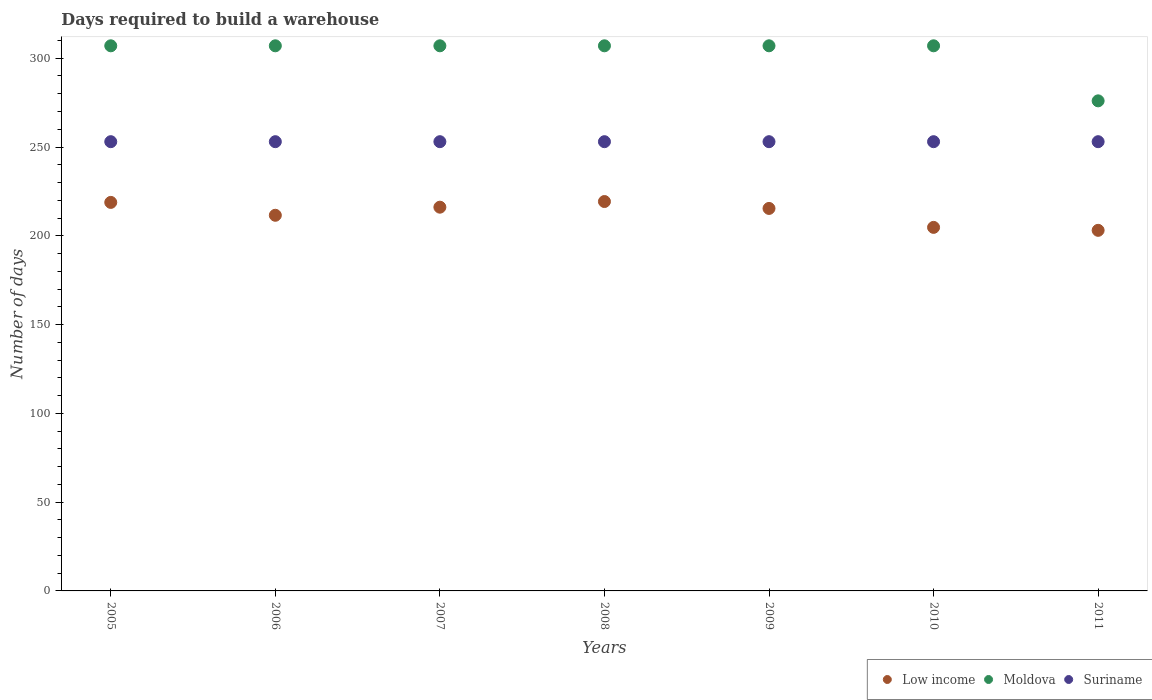Is the number of dotlines equal to the number of legend labels?
Provide a succinct answer. Yes. What is the days required to build a warehouse in in Low income in 2008?
Keep it short and to the point. 219.3. Across all years, what is the maximum days required to build a warehouse in in Moldova?
Your answer should be compact. 307. Across all years, what is the minimum days required to build a warehouse in in Suriname?
Keep it short and to the point. 253. What is the total days required to build a warehouse in in Suriname in the graph?
Make the answer very short. 1771. What is the difference between the days required to build a warehouse in in Moldova in 2006 and that in 2009?
Keep it short and to the point. 0. What is the difference between the days required to build a warehouse in in Moldova in 2009 and the days required to build a warehouse in in Low income in 2007?
Give a very brief answer. 90.89. What is the average days required to build a warehouse in in Low income per year?
Give a very brief answer. 212.71. In the year 2007, what is the difference between the days required to build a warehouse in in Low income and days required to build a warehouse in in Suriname?
Keep it short and to the point. -36.89. In how many years, is the days required to build a warehouse in in Moldova greater than 130 days?
Offer a very short reply. 7. What is the ratio of the days required to build a warehouse in in Suriname in 2006 to that in 2008?
Ensure brevity in your answer.  1. Is the difference between the days required to build a warehouse in in Low income in 2005 and 2011 greater than the difference between the days required to build a warehouse in in Suriname in 2005 and 2011?
Keep it short and to the point. Yes. What is the difference between the highest and the second highest days required to build a warehouse in in Suriname?
Your response must be concise. 0. What is the difference between the highest and the lowest days required to build a warehouse in in Suriname?
Provide a short and direct response. 0. In how many years, is the days required to build a warehouse in in Moldova greater than the average days required to build a warehouse in in Moldova taken over all years?
Offer a very short reply. 6. Is the sum of the days required to build a warehouse in in Moldova in 2005 and 2008 greater than the maximum days required to build a warehouse in in Low income across all years?
Give a very brief answer. Yes. Does the days required to build a warehouse in in Moldova monotonically increase over the years?
Ensure brevity in your answer.  No. Is the days required to build a warehouse in in Moldova strictly greater than the days required to build a warehouse in in Suriname over the years?
Ensure brevity in your answer.  Yes. Is the days required to build a warehouse in in Moldova strictly less than the days required to build a warehouse in in Low income over the years?
Your response must be concise. No. How many dotlines are there?
Give a very brief answer. 3. What is the difference between two consecutive major ticks on the Y-axis?
Give a very brief answer. 50. Are the values on the major ticks of Y-axis written in scientific E-notation?
Your response must be concise. No. Does the graph contain grids?
Ensure brevity in your answer.  No. Where does the legend appear in the graph?
Make the answer very short. Bottom right. How many legend labels are there?
Your response must be concise. 3. How are the legend labels stacked?
Give a very brief answer. Horizontal. What is the title of the graph?
Your response must be concise. Days required to build a warehouse. What is the label or title of the X-axis?
Provide a short and direct response. Years. What is the label or title of the Y-axis?
Your answer should be very brief. Number of days. What is the Number of days of Low income in 2005?
Your answer should be very brief. 218.81. What is the Number of days of Moldova in 2005?
Your response must be concise. 307. What is the Number of days of Suriname in 2005?
Offer a terse response. 253. What is the Number of days in Low income in 2006?
Ensure brevity in your answer.  211.56. What is the Number of days of Moldova in 2006?
Provide a short and direct response. 307. What is the Number of days in Suriname in 2006?
Offer a terse response. 253. What is the Number of days in Low income in 2007?
Make the answer very short. 216.11. What is the Number of days in Moldova in 2007?
Your response must be concise. 307. What is the Number of days of Suriname in 2007?
Give a very brief answer. 253. What is the Number of days in Low income in 2008?
Offer a very short reply. 219.3. What is the Number of days in Moldova in 2008?
Give a very brief answer. 307. What is the Number of days in Suriname in 2008?
Make the answer very short. 253. What is the Number of days of Low income in 2009?
Give a very brief answer. 215.41. What is the Number of days in Moldova in 2009?
Offer a terse response. 307. What is the Number of days in Suriname in 2009?
Provide a succinct answer. 253. What is the Number of days in Low income in 2010?
Ensure brevity in your answer.  204.74. What is the Number of days in Moldova in 2010?
Provide a succinct answer. 307. What is the Number of days of Suriname in 2010?
Offer a very short reply. 253. What is the Number of days of Low income in 2011?
Make the answer very short. 203.07. What is the Number of days of Moldova in 2011?
Offer a terse response. 276. What is the Number of days of Suriname in 2011?
Your answer should be compact. 253. Across all years, what is the maximum Number of days of Low income?
Keep it short and to the point. 219.3. Across all years, what is the maximum Number of days of Moldova?
Make the answer very short. 307. Across all years, what is the maximum Number of days in Suriname?
Offer a very short reply. 253. Across all years, what is the minimum Number of days of Low income?
Ensure brevity in your answer.  203.07. Across all years, what is the minimum Number of days of Moldova?
Provide a short and direct response. 276. Across all years, what is the minimum Number of days of Suriname?
Make the answer very short. 253. What is the total Number of days in Low income in the graph?
Make the answer very short. 1488.99. What is the total Number of days in Moldova in the graph?
Your answer should be compact. 2118. What is the total Number of days in Suriname in the graph?
Make the answer very short. 1771. What is the difference between the Number of days in Low income in 2005 and that in 2006?
Ensure brevity in your answer.  7.25. What is the difference between the Number of days of Low income in 2005 and that in 2007?
Offer a terse response. 2.7. What is the difference between the Number of days of Moldova in 2005 and that in 2007?
Your answer should be compact. 0. What is the difference between the Number of days of Suriname in 2005 and that in 2007?
Offer a terse response. 0. What is the difference between the Number of days in Low income in 2005 and that in 2008?
Provide a succinct answer. -0.49. What is the difference between the Number of days in Suriname in 2005 and that in 2008?
Ensure brevity in your answer.  0. What is the difference between the Number of days of Low income in 2005 and that in 2009?
Provide a succinct answer. 3.4. What is the difference between the Number of days of Low income in 2005 and that in 2010?
Ensure brevity in your answer.  14.07. What is the difference between the Number of days of Moldova in 2005 and that in 2010?
Provide a succinct answer. 0. What is the difference between the Number of days in Low income in 2005 and that in 2011?
Your response must be concise. 15.73. What is the difference between the Number of days of Suriname in 2005 and that in 2011?
Offer a very short reply. 0. What is the difference between the Number of days of Low income in 2006 and that in 2007?
Make the answer very short. -4.56. What is the difference between the Number of days in Low income in 2006 and that in 2008?
Offer a very short reply. -7.74. What is the difference between the Number of days in Moldova in 2006 and that in 2008?
Make the answer very short. 0. What is the difference between the Number of days of Suriname in 2006 and that in 2008?
Give a very brief answer. 0. What is the difference between the Number of days in Low income in 2006 and that in 2009?
Give a very brief answer. -3.85. What is the difference between the Number of days in Suriname in 2006 and that in 2009?
Provide a short and direct response. 0. What is the difference between the Number of days of Low income in 2006 and that in 2010?
Your answer should be very brief. 6.81. What is the difference between the Number of days of Low income in 2006 and that in 2011?
Keep it short and to the point. 8.48. What is the difference between the Number of days in Suriname in 2006 and that in 2011?
Provide a short and direct response. 0. What is the difference between the Number of days in Low income in 2007 and that in 2008?
Provide a succinct answer. -3.19. What is the difference between the Number of days of Suriname in 2007 and that in 2008?
Offer a terse response. 0. What is the difference between the Number of days in Low income in 2007 and that in 2009?
Your response must be concise. 0.7. What is the difference between the Number of days in Moldova in 2007 and that in 2009?
Ensure brevity in your answer.  0. What is the difference between the Number of days in Low income in 2007 and that in 2010?
Provide a short and direct response. 11.37. What is the difference between the Number of days in Moldova in 2007 and that in 2010?
Your answer should be very brief. 0. What is the difference between the Number of days of Suriname in 2007 and that in 2010?
Your response must be concise. 0. What is the difference between the Number of days of Low income in 2007 and that in 2011?
Give a very brief answer. 13.04. What is the difference between the Number of days of Moldova in 2007 and that in 2011?
Give a very brief answer. 31. What is the difference between the Number of days of Suriname in 2007 and that in 2011?
Offer a very short reply. 0. What is the difference between the Number of days of Low income in 2008 and that in 2009?
Ensure brevity in your answer.  3.89. What is the difference between the Number of days in Moldova in 2008 and that in 2009?
Provide a succinct answer. 0. What is the difference between the Number of days of Suriname in 2008 and that in 2009?
Your answer should be very brief. 0. What is the difference between the Number of days of Low income in 2008 and that in 2010?
Ensure brevity in your answer.  14.56. What is the difference between the Number of days of Moldova in 2008 and that in 2010?
Provide a succinct answer. 0. What is the difference between the Number of days in Low income in 2008 and that in 2011?
Provide a short and direct response. 16.22. What is the difference between the Number of days of Suriname in 2008 and that in 2011?
Your response must be concise. 0. What is the difference between the Number of days in Low income in 2009 and that in 2010?
Your response must be concise. 10.67. What is the difference between the Number of days of Moldova in 2009 and that in 2010?
Offer a terse response. 0. What is the difference between the Number of days of Suriname in 2009 and that in 2010?
Offer a very short reply. 0. What is the difference between the Number of days in Low income in 2009 and that in 2011?
Provide a short and direct response. 12.33. What is the difference between the Number of days in Suriname in 2010 and that in 2011?
Make the answer very short. 0. What is the difference between the Number of days in Low income in 2005 and the Number of days in Moldova in 2006?
Your response must be concise. -88.19. What is the difference between the Number of days of Low income in 2005 and the Number of days of Suriname in 2006?
Provide a succinct answer. -34.19. What is the difference between the Number of days of Low income in 2005 and the Number of days of Moldova in 2007?
Provide a short and direct response. -88.19. What is the difference between the Number of days of Low income in 2005 and the Number of days of Suriname in 2007?
Provide a succinct answer. -34.19. What is the difference between the Number of days in Moldova in 2005 and the Number of days in Suriname in 2007?
Your response must be concise. 54. What is the difference between the Number of days of Low income in 2005 and the Number of days of Moldova in 2008?
Your answer should be very brief. -88.19. What is the difference between the Number of days in Low income in 2005 and the Number of days in Suriname in 2008?
Your answer should be very brief. -34.19. What is the difference between the Number of days of Moldova in 2005 and the Number of days of Suriname in 2008?
Ensure brevity in your answer.  54. What is the difference between the Number of days of Low income in 2005 and the Number of days of Moldova in 2009?
Provide a succinct answer. -88.19. What is the difference between the Number of days of Low income in 2005 and the Number of days of Suriname in 2009?
Your answer should be compact. -34.19. What is the difference between the Number of days of Low income in 2005 and the Number of days of Moldova in 2010?
Make the answer very short. -88.19. What is the difference between the Number of days of Low income in 2005 and the Number of days of Suriname in 2010?
Give a very brief answer. -34.19. What is the difference between the Number of days in Low income in 2005 and the Number of days in Moldova in 2011?
Make the answer very short. -57.19. What is the difference between the Number of days in Low income in 2005 and the Number of days in Suriname in 2011?
Keep it short and to the point. -34.19. What is the difference between the Number of days in Low income in 2006 and the Number of days in Moldova in 2007?
Your answer should be compact. -95.44. What is the difference between the Number of days of Low income in 2006 and the Number of days of Suriname in 2007?
Ensure brevity in your answer.  -41.44. What is the difference between the Number of days of Moldova in 2006 and the Number of days of Suriname in 2007?
Give a very brief answer. 54. What is the difference between the Number of days in Low income in 2006 and the Number of days in Moldova in 2008?
Keep it short and to the point. -95.44. What is the difference between the Number of days in Low income in 2006 and the Number of days in Suriname in 2008?
Your answer should be compact. -41.44. What is the difference between the Number of days in Low income in 2006 and the Number of days in Moldova in 2009?
Your answer should be compact. -95.44. What is the difference between the Number of days in Low income in 2006 and the Number of days in Suriname in 2009?
Provide a succinct answer. -41.44. What is the difference between the Number of days in Low income in 2006 and the Number of days in Moldova in 2010?
Provide a short and direct response. -95.44. What is the difference between the Number of days in Low income in 2006 and the Number of days in Suriname in 2010?
Offer a terse response. -41.44. What is the difference between the Number of days of Moldova in 2006 and the Number of days of Suriname in 2010?
Keep it short and to the point. 54. What is the difference between the Number of days in Low income in 2006 and the Number of days in Moldova in 2011?
Give a very brief answer. -64.44. What is the difference between the Number of days in Low income in 2006 and the Number of days in Suriname in 2011?
Make the answer very short. -41.44. What is the difference between the Number of days in Moldova in 2006 and the Number of days in Suriname in 2011?
Provide a short and direct response. 54. What is the difference between the Number of days of Low income in 2007 and the Number of days of Moldova in 2008?
Ensure brevity in your answer.  -90.89. What is the difference between the Number of days of Low income in 2007 and the Number of days of Suriname in 2008?
Your answer should be very brief. -36.89. What is the difference between the Number of days of Moldova in 2007 and the Number of days of Suriname in 2008?
Offer a very short reply. 54. What is the difference between the Number of days of Low income in 2007 and the Number of days of Moldova in 2009?
Your answer should be compact. -90.89. What is the difference between the Number of days in Low income in 2007 and the Number of days in Suriname in 2009?
Offer a terse response. -36.89. What is the difference between the Number of days in Low income in 2007 and the Number of days in Moldova in 2010?
Ensure brevity in your answer.  -90.89. What is the difference between the Number of days of Low income in 2007 and the Number of days of Suriname in 2010?
Provide a succinct answer. -36.89. What is the difference between the Number of days of Moldova in 2007 and the Number of days of Suriname in 2010?
Provide a short and direct response. 54. What is the difference between the Number of days of Low income in 2007 and the Number of days of Moldova in 2011?
Your answer should be compact. -59.89. What is the difference between the Number of days in Low income in 2007 and the Number of days in Suriname in 2011?
Keep it short and to the point. -36.89. What is the difference between the Number of days of Moldova in 2007 and the Number of days of Suriname in 2011?
Make the answer very short. 54. What is the difference between the Number of days in Low income in 2008 and the Number of days in Moldova in 2009?
Provide a short and direct response. -87.7. What is the difference between the Number of days of Low income in 2008 and the Number of days of Suriname in 2009?
Provide a short and direct response. -33.7. What is the difference between the Number of days of Low income in 2008 and the Number of days of Moldova in 2010?
Offer a very short reply. -87.7. What is the difference between the Number of days in Low income in 2008 and the Number of days in Suriname in 2010?
Offer a very short reply. -33.7. What is the difference between the Number of days of Moldova in 2008 and the Number of days of Suriname in 2010?
Your response must be concise. 54. What is the difference between the Number of days of Low income in 2008 and the Number of days of Moldova in 2011?
Make the answer very short. -56.7. What is the difference between the Number of days in Low income in 2008 and the Number of days in Suriname in 2011?
Offer a very short reply. -33.7. What is the difference between the Number of days of Low income in 2009 and the Number of days of Moldova in 2010?
Keep it short and to the point. -91.59. What is the difference between the Number of days in Low income in 2009 and the Number of days in Suriname in 2010?
Keep it short and to the point. -37.59. What is the difference between the Number of days of Low income in 2009 and the Number of days of Moldova in 2011?
Provide a short and direct response. -60.59. What is the difference between the Number of days of Low income in 2009 and the Number of days of Suriname in 2011?
Give a very brief answer. -37.59. What is the difference between the Number of days in Low income in 2010 and the Number of days in Moldova in 2011?
Ensure brevity in your answer.  -71.26. What is the difference between the Number of days of Low income in 2010 and the Number of days of Suriname in 2011?
Keep it short and to the point. -48.26. What is the average Number of days in Low income per year?
Your answer should be very brief. 212.71. What is the average Number of days in Moldova per year?
Offer a very short reply. 302.57. What is the average Number of days in Suriname per year?
Your answer should be compact. 253. In the year 2005, what is the difference between the Number of days of Low income and Number of days of Moldova?
Provide a succinct answer. -88.19. In the year 2005, what is the difference between the Number of days in Low income and Number of days in Suriname?
Your answer should be very brief. -34.19. In the year 2005, what is the difference between the Number of days in Moldova and Number of days in Suriname?
Make the answer very short. 54. In the year 2006, what is the difference between the Number of days of Low income and Number of days of Moldova?
Make the answer very short. -95.44. In the year 2006, what is the difference between the Number of days of Low income and Number of days of Suriname?
Ensure brevity in your answer.  -41.44. In the year 2006, what is the difference between the Number of days in Moldova and Number of days in Suriname?
Keep it short and to the point. 54. In the year 2007, what is the difference between the Number of days of Low income and Number of days of Moldova?
Offer a terse response. -90.89. In the year 2007, what is the difference between the Number of days in Low income and Number of days in Suriname?
Offer a very short reply. -36.89. In the year 2008, what is the difference between the Number of days in Low income and Number of days in Moldova?
Offer a terse response. -87.7. In the year 2008, what is the difference between the Number of days of Low income and Number of days of Suriname?
Your answer should be very brief. -33.7. In the year 2009, what is the difference between the Number of days of Low income and Number of days of Moldova?
Your response must be concise. -91.59. In the year 2009, what is the difference between the Number of days in Low income and Number of days in Suriname?
Provide a succinct answer. -37.59. In the year 2009, what is the difference between the Number of days in Moldova and Number of days in Suriname?
Offer a very short reply. 54. In the year 2010, what is the difference between the Number of days of Low income and Number of days of Moldova?
Offer a terse response. -102.26. In the year 2010, what is the difference between the Number of days of Low income and Number of days of Suriname?
Ensure brevity in your answer.  -48.26. In the year 2011, what is the difference between the Number of days of Low income and Number of days of Moldova?
Provide a short and direct response. -72.93. In the year 2011, what is the difference between the Number of days in Low income and Number of days in Suriname?
Your response must be concise. -49.93. In the year 2011, what is the difference between the Number of days of Moldova and Number of days of Suriname?
Your answer should be very brief. 23. What is the ratio of the Number of days in Low income in 2005 to that in 2006?
Offer a terse response. 1.03. What is the ratio of the Number of days in Suriname in 2005 to that in 2006?
Ensure brevity in your answer.  1. What is the ratio of the Number of days in Low income in 2005 to that in 2007?
Your response must be concise. 1.01. What is the ratio of the Number of days of Moldova in 2005 to that in 2007?
Your answer should be very brief. 1. What is the ratio of the Number of days in Low income in 2005 to that in 2008?
Make the answer very short. 1. What is the ratio of the Number of days of Moldova in 2005 to that in 2008?
Give a very brief answer. 1. What is the ratio of the Number of days in Suriname in 2005 to that in 2008?
Make the answer very short. 1. What is the ratio of the Number of days in Low income in 2005 to that in 2009?
Give a very brief answer. 1.02. What is the ratio of the Number of days of Moldova in 2005 to that in 2009?
Provide a short and direct response. 1. What is the ratio of the Number of days in Suriname in 2005 to that in 2009?
Make the answer very short. 1. What is the ratio of the Number of days in Low income in 2005 to that in 2010?
Offer a very short reply. 1.07. What is the ratio of the Number of days of Moldova in 2005 to that in 2010?
Provide a short and direct response. 1. What is the ratio of the Number of days in Low income in 2005 to that in 2011?
Your answer should be very brief. 1.08. What is the ratio of the Number of days in Moldova in 2005 to that in 2011?
Your answer should be compact. 1.11. What is the ratio of the Number of days in Low income in 2006 to that in 2007?
Keep it short and to the point. 0.98. What is the ratio of the Number of days in Moldova in 2006 to that in 2007?
Ensure brevity in your answer.  1. What is the ratio of the Number of days in Suriname in 2006 to that in 2007?
Offer a very short reply. 1. What is the ratio of the Number of days in Low income in 2006 to that in 2008?
Provide a succinct answer. 0.96. What is the ratio of the Number of days of Low income in 2006 to that in 2009?
Provide a succinct answer. 0.98. What is the ratio of the Number of days of Low income in 2006 to that in 2010?
Your response must be concise. 1.03. What is the ratio of the Number of days of Moldova in 2006 to that in 2010?
Ensure brevity in your answer.  1. What is the ratio of the Number of days in Low income in 2006 to that in 2011?
Offer a very short reply. 1.04. What is the ratio of the Number of days of Moldova in 2006 to that in 2011?
Offer a very short reply. 1.11. What is the ratio of the Number of days of Suriname in 2006 to that in 2011?
Provide a succinct answer. 1. What is the ratio of the Number of days in Low income in 2007 to that in 2008?
Offer a terse response. 0.99. What is the ratio of the Number of days in Low income in 2007 to that in 2009?
Make the answer very short. 1. What is the ratio of the Number of days in Low income in 2007 to that in 2010?
Keep it short and to the point. 1.06. What is the ratio of the Number of days in Suriname in 2007 to that in 2010?
Make the answer very short. 1. What is the ratio of the Number of days in Low income in 2007 to that in 2011?
Give a very brief answer. 1.06. What is the ratio of the Number of days of Moldova in 2007 to that in 2011?
Your answer should be compact. 1.11. What is the ratio of the Number of days in Suriname in 2007 to that in 2011?
Ensure brevity in your answer.  1. What is the ratio of the Number of days of Low income in 2008 to that in 2009?
Your response must be concise. 1.02. What is the ratio of the Number of days of Moldova in 2008 to that in 2009?
Your response must be concise. 1. What is the ratio of the Number of days in Suriname in 2008 to that in 2009?
Provide a short and direct response. 1. What is the ratio of the Number of days in Low income in 2008 to that in 2010?
Provide a short and direct response. 1.07. What is the ratio of the Number of days of Moldova in 2008 to that in 2010?
Your response must be concise. 1. What is the ratio of the Number of days in Low income in 2008 to that in 2011?
Make the answer very short. 1.08. What is the ratio of the Number of days of Moldova in 2008 to that in 2011?
Offer a terse response. 1.11. What is the ratio of the Number of days in Low income in 2009 to that in 2010?
Make the answer very short. 1.05. What is the ratio of the Number of days in Suriname in 2009 to that in 2010?
Provide a succinct answer. 1. What is the ratio of the Number of days of Low income in 2009 to that in 2011?
Provide a short and direct response. 1.06. What is the ratio of the Number of days of Moldova in 2009 to that in 2011?
Offer a terse response. 1.11. What is the ratio of the Number of days of Low income in 2010 to that in 2011?
Your answer should be compact. 1.01. What is the ratio of the Number of days in Moldova in 2010 to that in 2011?
Offer a very short reply. 1.11. What is the difference between the highest and the second highest Number of days of Low income?
Provide a succinct answer. 0.49. What is the difference between the highest and the second highest Number of days of Moldova?
Offer a terse response. 0. What is the difference between the highest and the lowest Number of days in Low income?
Your answer should be compact. 16.22. What is the difference between the highest and the lowest Number of days of Moldova?
Ensure brevity in your answer.  31. 